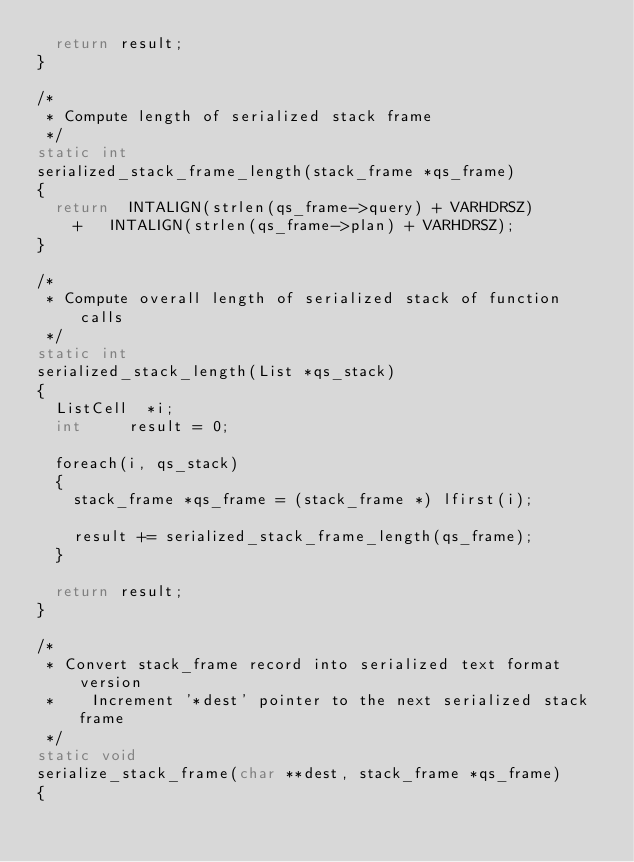Convert code to text. <code><loc_0><loc_0><loc_500><loc_500><_C_>	return result;
}

/*
 * Compute length of serialized stack frame
 */
static int
serialized_stack_frame_length(stack_frame *qs_frame)
{
	return 	INTALIGN(strlen(qs_frame->query) + VARHDRSZ)
		+ 	INTALIGN(strlen(qs_frame->plan) + VARHDRSZ);
}

/*
 * Compute overall length of serialized stack of function calls
 */
static int
serialized_stack_length(List *qs_stack)
{
	ListCell 	*i;
	int			result = 0;

	foreach(i, qs_stack)
	{
		stack_frame *qs_frame = (stack_frame *) lfirst(i);

		result += serialized_stack_frame_length(qs_frame);
	}

	return result;
}

/*
 * Convert stack_frame record into serialized text format version
 * 		Increment '*dest' pointer to the next serialized stack frame
 */
static void
serialize_stack_frame(char **dest, stack_frame *qs_frame)
{</code> 